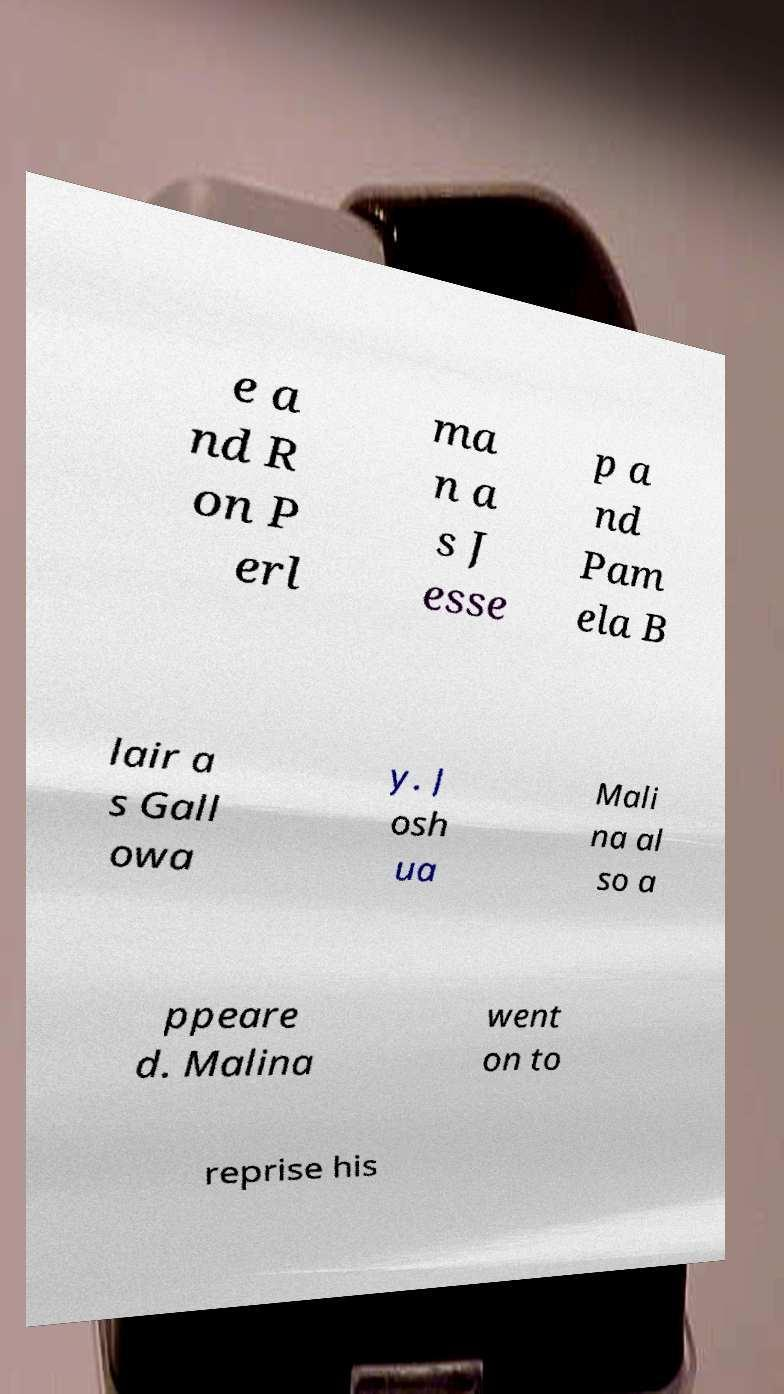What messages or text are displayed in this image? I need them in a readable, typed format. e a nd R on P erl ma n a s J esse p a nd Pam ela B lair a s Gall owa y. J osh ua Mali na al so a ppeare d. Malina went on to reprise his 